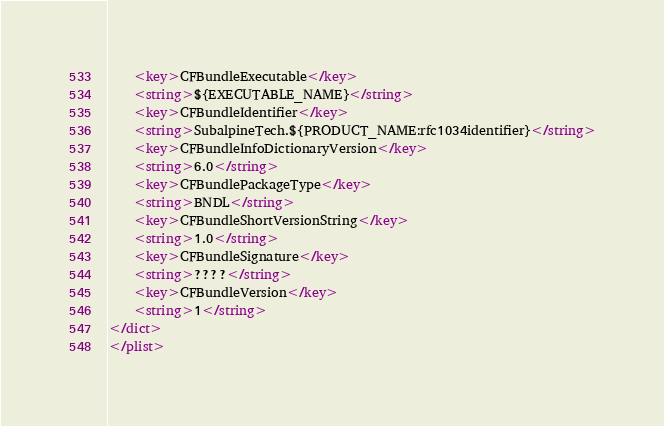Convert code to text. <code><loc_0><loc_0><loc_500><loc_500><_XML_>	<key>CFBundleExecutable</key>
	<string>${EXECUTABLE_NAME}</string>
	<key>CFBundleIdentifier</key>
	<string>SubalpineTech.${PRODUCT_NAME:rfc1034identifier}</string>
	<key>CFBundleInfoDictionaryVersion</key>
	<string>6.0</string>
	<key>CFBundlePackageType</key>
	<string>BNDL</string>
	<key>CFBundleShortVersionString</key>
	<string>1.0</string>
	<key>CFBundleSignature</key>
	<string>????</string>
	<key>CFBundleVersion</key>
	<string>1</string>
</dict>
</plist>
</code> 